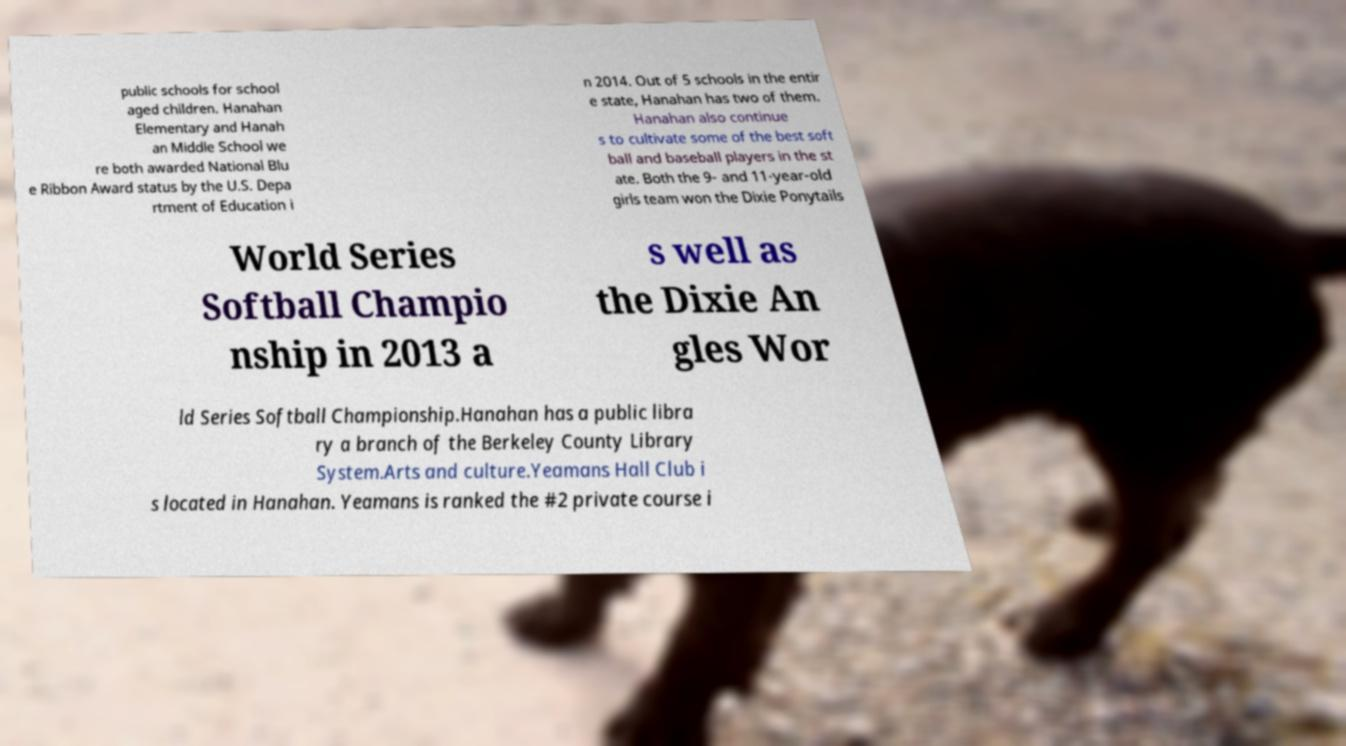Could you extract and type out the text from this image? public schools for school aged children. Hanahan Elementary and Hanah an Middle School we re both awarded National Blu e Ribbon Award status by the U.S. Depa rtment of Education i n 2014. Out of 5 schools in the entir e state, Hanahan has two of them. Hanahan also continue s to cultivate some of the best soft ball and baseball players in the st ate. Both the 9- and 11-year-old girls team won the Dixie Ponytails World Series Softball Champio nship in 2013 a s well as the Dixie An gles Wor ld Series Softball Championship.Hanahan has a public libra ry a branch of the Berkeley County Library System.Arts and culture.Yeamans Hall Club i s located in Hanahan. Yeamans is ranked the #2 private course i 